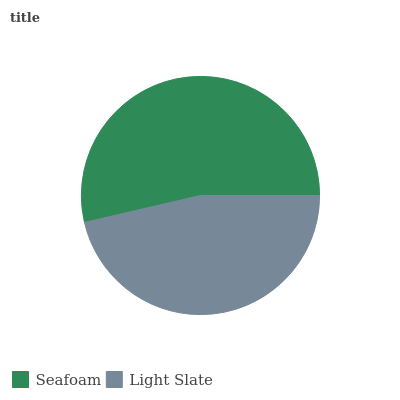Is Light Slate the minimum?
Answer yes or no. Yes. Is Seafoam the maximum?
Answer yes or no. Yes. Is Light Slate the maximum?
Answer yes or no. No. Is Seafoam greater than Light Slate?
Answer yes or no. Yes. Is Light Slate less than Seafoam?
Answer yes or no. Yes. Is Light Slate greater than Seafoam?
Answer yes or no. No. Is Seafoam less than Light Slate?
Answer yes or no. No. Is Seafoam the high median?
Answer yes or no. Yes. Is Light Slate the low median?
Answer yes or no. Yes. Is Light Slate the high median?
Answer yes or no. No. Is Seafoam the low median?
Answer yes or no. No. 